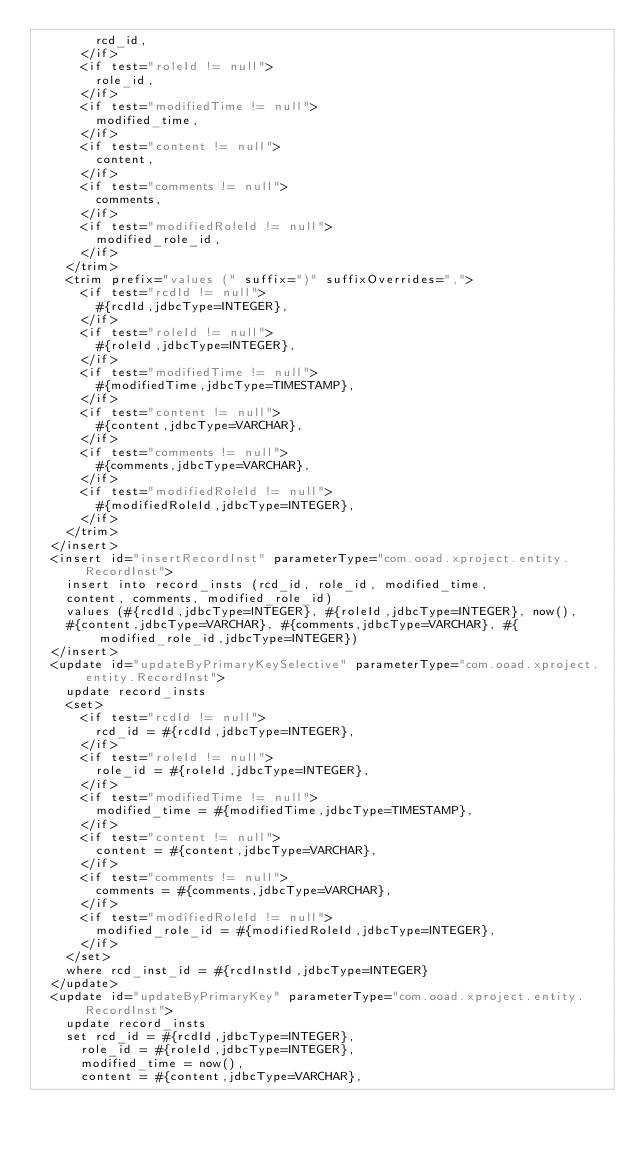Convert code to text. <code><loc_0><loc_0><loc_500><loc_500><_XML_>        rcd_id,
      </if>
      <if test="roleId != null">
        role_id,
      </if>
      <if test="modifiedTime != null">
        modified_time,
      </if>
      <if test="content != null">
        content,
      </if>
      <if test="comments != null">
        comments,
      </if>
      <if test="modifiedRoleId != null">
        modified_role_id,
      </if>
    </trim>
    <trim prefix="values (" suffix=")" suffixOverrides=",">
      <if test="rcdId != null">
        #{rcdId,jdbcType=INTEGER},
      </if>
      <if test="roleId != null">
        #{roleId,jdbcType=INTEGER},
      </if>
      <if test="modifiedTime != null">
        #{modifiedTime,jdbcType=TIMESTAMP},
      </if>
      <if test="content != null">
        #{content,jdbcType=VARCHAR},
      </if>
      <if test="comments != null">
        #{comments,jdbcType=VARCHAR},
      </if>
      <if test="modifiedRoleId != null">
        #{modifiedRoleId,jdbcType=INTEGER},
      </if>
    </trim>
  </insert>
  <insert id="insertRecordInst" parameterType="com.ooad.xproject.entity.RecordInst">
    insert into record_insts (rcd_id, role_id, modified_time,
    content, comments, modified_role_id)
    values (#{rcdId,jdbcType=INTEGER}, #{roleId,jdbcType=INTEGER}, now(),
    #{content,jdbcType=VARCHAR}, #{comments,jdbcType=VARCHAR}, #{modified_role_id,jdbcType=INTEGER})
  </insert>
  <update id="updateByPrimaryKeySelective" parameterType="com.ooad.xproject.entity.RecordInst">
    update record_insts
    <set>
      <if test="rcdId != null">
        rcd_id = #{rcdId,jdbcType=INTEGER},
      </if>
      <if test="roleId != null">
        role_id = #{roleId,jdbcType=INTEGER},
      </if>
      <if test="modifiedTime != null">
        modified_time = #{modifiedTime,jdbcType=TIMESTAMP},
      </if>
      <if test="content != null">
        content = #{content,jdbcType=VARCHAR},
      </if>
      <if test="comments != null">
        comments = #{comments,jdbcType=VARCHAR},
      </if>
      <if test="modifiedRoleId != null">
        modified_role_id = #{modifiedRoleId,jdbcType=INTEGER},
      </if>
    </set>
    where rcd_inst_id = #{rcdInstId,jdbcType=INTEGER}
  </update>
  <update id="updateByPrimaryKey" parameterType="com.ooad.xproject.entity.RecordInst">
    update record_insts
    set rcd_id = #{rcdId,jdbcType=INTEGER},
      role_id = #{roleId,jdbcType=INTEGER},
      modified_time = now(),
      content = #{content,jdbcType=VARCHAR},</code> 